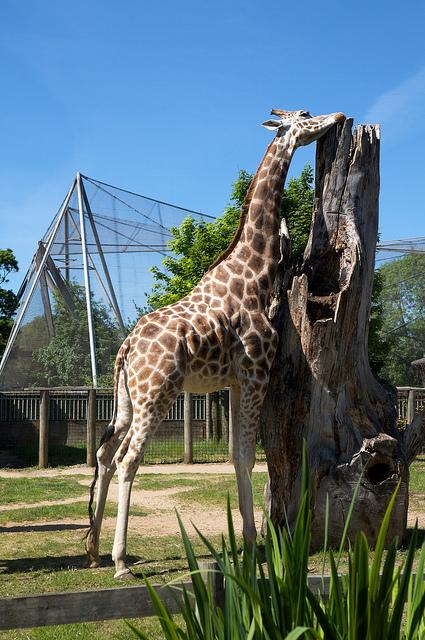What is about the same height as the giraffe?
Answer briefly. Stump. What are the giraffes reaching for?
Short answer required. Food. How many giraffe's are eating?
Give a very brief answer. 1. Is the giraffe touching with its mouth?
Be succinct. Yes. Is it shot in the wild?
Write a very short answer. No. What type of fence is in the background?
Be succinct. Wooden. Is this giraffe in the wild?
Give a very brief answer. No. 